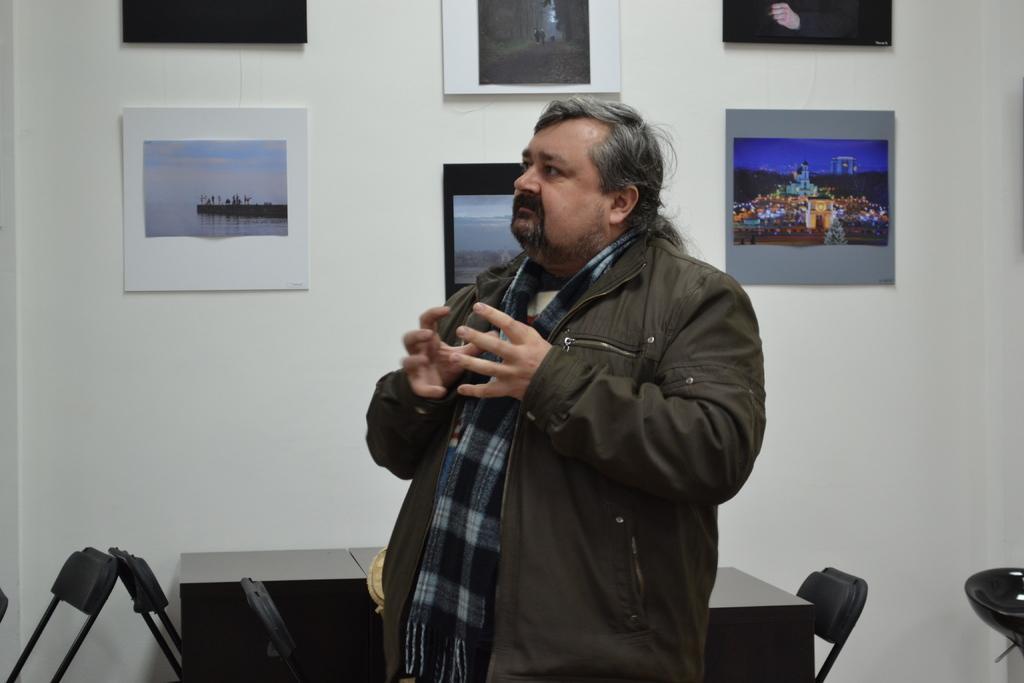Describe this image in one or two sentences. In the center of the image there is a person wearing a jacket. In the background of the image there is a wall with poster on it. There is a table. There are chairs. 